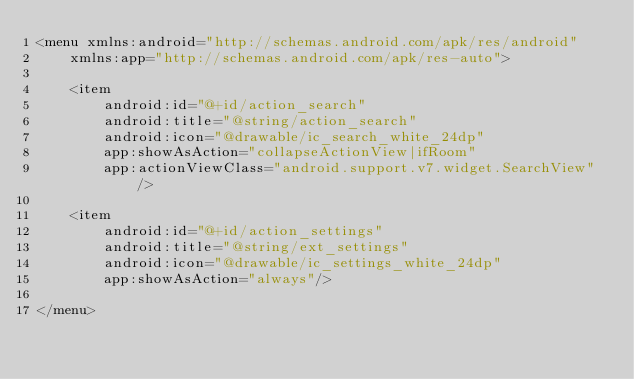Convert code to text. <code><loc_0><loc_0><loc_500><loc_500><_XML_><menu xmlns:android="http://schemas.android.com/apk/res/android"
    xmlns:app="http://schemas.android.com/apk/res-auto">

    <item
        android:id="@+id/action_search"
        android:title="@string/action_search"
        android:icon="@drawable/ic_search_white_24dp"
        app:showAsAction="collapseActionView|ifRoom"
        app:actionViewClass="android.support.v7.widget.SearchView"/>

    <item
        android:id="@+id/action_settings"
        android:title="@string/ext_settings"
        android:icon="@drawable/ic_settings_white_24dp"
        app:showAsAction="always"/>

</menu>
</code> 